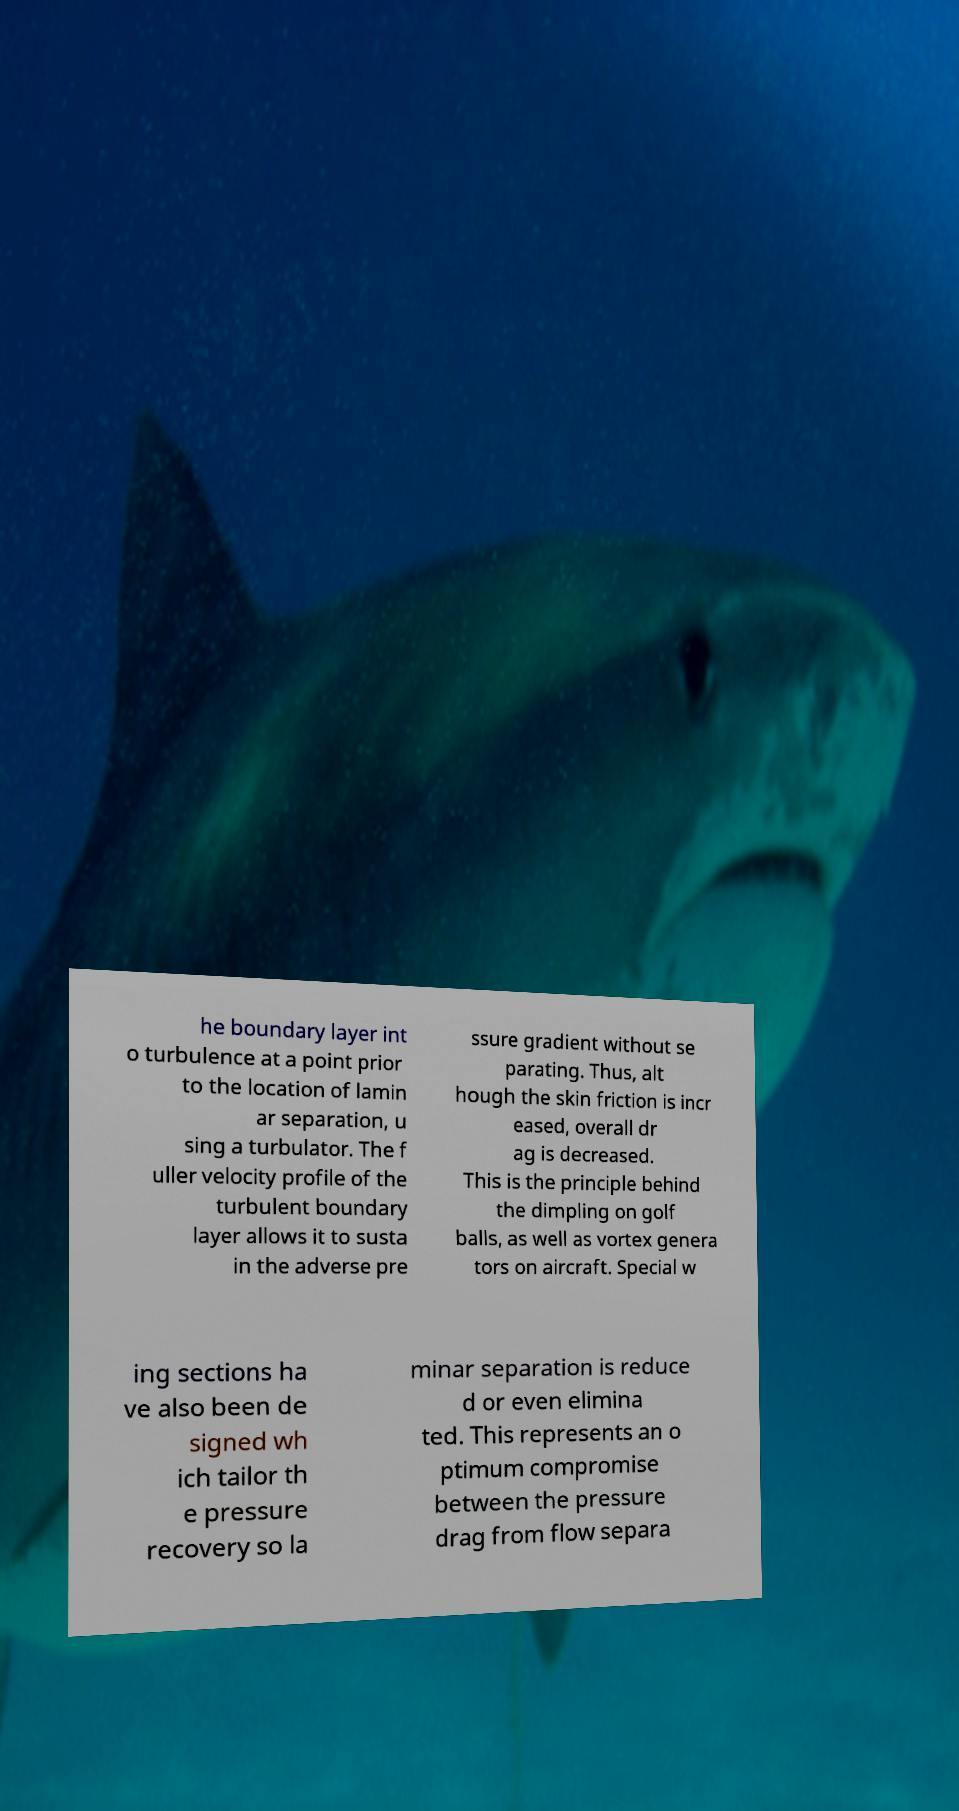I need the written content from this picture converted into text. Can you do that? he boundary layer int o turbulence at a point prior to the location of lamin ar separation, u sing a turbulator. The f uller velocity profile of the turbulent boundary layer allows it to susta in the adverse pre ssure gradient without se parating. Thus, alt hough the skin friction is incr eased, overall dr ag is decreased. This is the principle behind the dimpling on golf balls, as well as vortex genera tors on aircraft. Special w ing sections ha ve also been de signed wh ich tailor th e pressure recovery so la minar separation is reduce d or even elimina ted. This represents an o ptimum compromise between the pressure drag from flow separa 